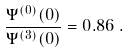<formula> <loc_0><loc_0><loc_500><loc_500>\frac { \Psi ^ { ( 0 ) } ( 0 ) } { \Psi ^ { ( 3 ) } ( 0 ) } = 0 . 8 6 \, .</formula> 